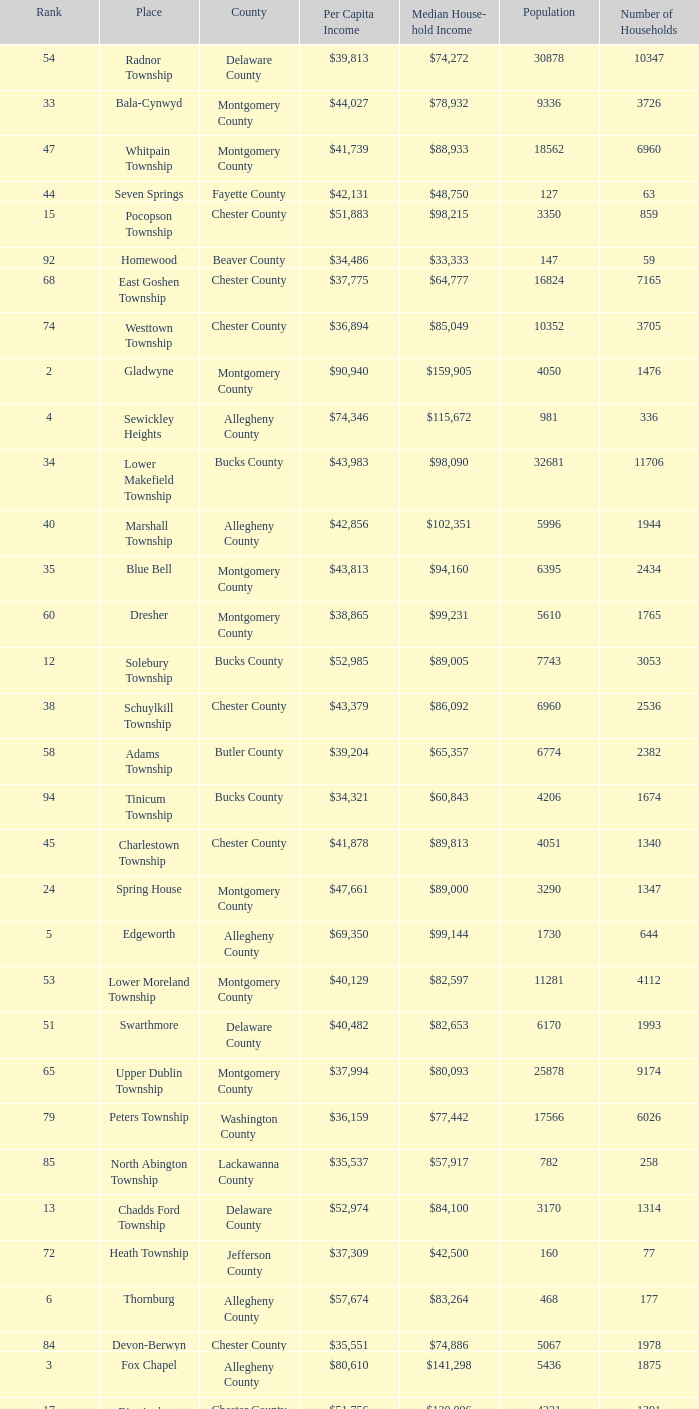Parse the full table. {'header': ['Rank', 'Place', 'County', 'Per Capita Income', 'Median House- hold Income', 'Population', 'Number of Households'], 'rows': [['54', 'Radnor Township', 'Delaware County', '$39,813', '$74,272', '30878', '10347'], ['33', 'Bala-Cynwyd', 'Montgomery County', '$44,027', '$78,932', '9336', '3726'], ['47', 'Whitpain Township', 'Montgomery County', '$41,739', '$88,933', '18562', '6960'], ['44', 'Seven Springs', 'Fayette County', '$42,131', '$48,750', '127', '63'], ['15', 'Pocopson Township', 'Chester County', '$51,883', '$98,215', '3350', '859'], ['92', 'Homewood', 'Beaver County', '$34,486', '$33,333', '147', '59'], ['68', 'East Goshen Township', 'Chester County', '$37,775', '$64,777', '16824', '7165'], ['74', 'Westtown Township', 'Chester County', '$36,894', '$85,049', '10352', '3705'], ['2', 'Gladwyne', 'Montgomery County', '$90,940', '$159,905', '4050', '1476'], ['4', 'Sewickley Heights', 'Allegheny County', '$74,346', '$115,672', '981', '336'], ['34', 'Lower Makefield Township', 'Bucks County', '$43,983', '$98,090', '32681', '11706'], ['40', 'Marshall Township', 'Allegheny County', '$42,856', '$102,351', '5996', '1944'], ['35', 'Blue Bell', 'Montgomery County', '$43,813', '$94,160', '6395', '2434'], ['60', 'Dresher', 'Montgomery County', '$38,865', '$99,231', '5610', '1765'], ['12', 'Solebury Township', 'Bucks County', '$52,985', '$89,005', '7743', '3053'], ['38', 'Schuylkill Township', 'Chester County', '$43,379', '$86,092', '6960', '2536'], ['58', 'Adams Township', 'Butler County', '$39,204', '$65,357', '6774', '2382'], ['94', 'Tinicum Township', 'Bucks County', '$34,321', '$60,843', '4206', '1674'], ['45', 'Charlestown Township', 'Chester County', '$41,878', '$89,813', '4051', '1340'], ['24', 'Spring House', 'Montgomery County', '$47,661', '$89,000', '3290', '1347'], ['5', 'Edgeworth', 'Allegheny County', '$69,350', '$99,144', '1730', '644'], ['53', 'Lower Moreland Township', 'Montgomery County', '$40,129', '$82,597', '11281', '4112'], ['51', 'Swarthmore', 'Delaware County', '$40,482', '$82,653', '6170', '1993'], ['65', 'Upper Dublin Township', 'Montgomery County', '$37,994', '$80,093', '25878', '9174'], ['79', 'Peters Township', 'Washington County', '$36,159', '$77,442', '17566', '6026'], ['85', 'North Abington Township', 'Lackawanna County', '$35,537', '$57,917', '782', '258'], ['13', 'Chadds Ford Township', 'Delaware County', '$52,974', '$84,100', '3170', '1314'], ['72', 'Heath Township', 'Jefferson County', '$37,309', '$42,500', '160', '77'], ['6', 'Thornburg', 'Allegheny County', '$57,674', '$83,264', '468', '177'], ['84', 'Devon-Berwyn', 'Chester County', '$35,551', '$74,886', '5067', '1978'], ['3', 'Fox Chapel', 'Allegheny County', '$80,610', '$141,298', '5436', '1875'], ['17', 'Birmingham Township', 'Chester County', '$51,756', '$130,096', '4221', '1391'], ['19', 'Easttown Township', 'Chester County', '$51,028', '$95,548', '10270', '3758'], ['80', 'Ardmore', 'Montgomery County', '$36,111', '$60,966', '12616', '5529'], ['31', 'Abington Township', 'Lackawanna County', '$44,551', '$73,611', '1616', '609'], ['77', 'Newlin Township', 'Chester County', '$36,804', '$68,828', '1150', '429'], ['21', 'Osborne', 'Allegheny County', '$50,169', '$64,375', '566', '216'], ['76', 'Flying Hills', 'Berks County', '$36,822', '$59,596', '1191', '592'], ['25', 'Tredyffrin Township', 'Chester County', '$47,584', '$82,258', '29062', '12223'], ['64', 'Doylestown Township', 'Bucks County', '$38,031', '$81,226', '17619', '5999'], ['63', 'East Marlborough Township', 'Chester County', '$38,090', '$95,812', '6317', '2131'], ['82', 'London Britain Township', 'Chester County', '$35,761', '$93,521', '2797', '957'], ['1', 'Norwin', 'Westmoreland County', '$124,279', '$94,239', '18', '7'], ['96', 'Wyomissing Hills', 'Berks County', '$34,024', '$61,364', '2568', '986'], ['56', 'Upper Providence Township', 'Delaware County', '$39,532', '$71,166', '10509', '4075'], ['23', 'Spring Ridge', 'Berks County', '$47,822', '$83,345', '786', '370'], ['28', 'Kennett Township', 'Chester County', '$46,669', '$85,104', '6451', '2457'], ['73', 'Aleppo Township', 'Allegheny County', '$37,187', '$59,167', '1039', '483'], ['49', 'Penn Wynne', 'Montgomery County', '$41,199', '$78,398', '5382', '2072'], ['36', 'West Vincent Township', 'Chester County', '$43,500', '$92,024', '3170', '1077'], ['26', 'Thornbury Township', 'Chester County', '$47,505', '$84,225', '2678', '1023'], ['18', 'Bradford Woods', 'Allegheny County', '$51,462', '$92,820', '1149', '464'], ['66', 'Churchill', 'Allegheny County', '$37,964', '$67,321', '3566', '1519'], ['11', 'Haysville', 'Allegheny County', '$53,151', '$33,750', '78', '36'], ['22', 'West Pikeland Township', 'Chester County', '$48,616', '$105,322', '3551', '1214'], ['59', 'Edgewood', 'Allegheny County', '$39,188', '$52,153', '3311', '1639'], ['43', 'Upper St.Clair Township', 'Allegheny County', '$42,413', '$87,581', '20053', '6966'], ['90', 'Timber Hills', 'Lebanon County', '$34,974', '$55,938', '329', '157'], ['57', 'Newtown Township', 'Delaware County', '$39,364', '$65,924', '11700', '4549'], ['67', 'Franklin Park', 'Allegheny County', '$37,924', '$87,627', '11364', '3866'], ['61', 'Sewickley Hills', 'Allegheny County', '$38,681', '$79,466', '652', '225'], ['62', 'Exton', 'Chester County', '$38,589', '$68,240', '4267', '2053'], ['91', 'Upper Merion Township', 'Montgomery County', '$34,961', '$65,636', '26863', '11575'], ['27', 'Edgmont Township', 'Delaware County', '$46,848', '$88,303', '3918', '1447'], ['98', 'Concord Township', 'Delaware County', '$33,800', '$85,503', '9933', '3384'], ['41', 'Woodside', 'Bucks County', '$42,653', '$121,151', '2575', '791'], ['29', 'New Hope', 'Bucks County', '$45,309', '$60,833', '2252', '1160'], ['30', 'Willistown', 'Chester County', '$45,010', '$77,555', '10011', '3806'], ['9', 'Lower Merion Township', 'Montgomery County', '$55,526', '$86,373', '59850', '22868'], ['93', 'Newtown Township', 'Bucks County', '$34,335', '$80,532', '18206', '6761'], ['37', 'Mount Gretna', 'Lebanon County', '$43,470', '$62,917', '242', '117'], ['32', 'Ben Avon Heights', 'Allegheny County', '$44,191', '$105,006', '392', '138'], ['86', 'Malvern', 'Chester County', '$35,477', '$62,308', '3059', '1361'], ['52', 'Lafayette Hill', 'Montgomery County', '$40,363', '$84,835', '10226', '3783'], ['42', 'Wrightstown Township', 'Bucks County', '$42,623', '$82,875', '2839', '971'], ['8', 'Upper Makefield Township', 'Bucks County', '$56,288', '$102,759', '7180', '2512'], ['83', 'Buckingham Township', 'Bucks County', '$35,735', '$82,376', '16422', '5711'], ['46', 'Lower Gwynedd Township', 'Montgomery County', '$41,868', '$74,351', '10422', '4177'], ['50', 'East Bradford Township', 'Chester County', '$41,158', '$100,732', '9405', '3076'], ['71', 'Wyomissing', 'Berks County', '$37,313', '$54,681', '8587', '3359'], ['14', 'Pennsbury Township', 'Chester County', '$52,530', '$83,295', '3500', '1387'], ['48', 'Bell Acres', 'Allegheny County', '$41,202', '$61,094', '1382', '520'], ['20', 'Villanova', 'Montgomery County', '$50,204', '$159,538', '9060', '1902'], ['16', 'Chesterbrook', 'Chester County', '$51,859', '$80,792', '4625', '2356'], ['7', 'Rosslyn Farms', 'Allegheny County', '$56,612', '$87,500', '464', '184'], ['89', 'West Whiteland Township', 'Chester County', '$35,031', '$71,545', '16499', '6618'], ['10', 'Rose Valley', 'Delaware County', '$54,202', '$114,373', '944', '347'], ['55', 'Whitemarsh Township', 'Montgomery County', '$39,785', '$78,630', '16702', '6179'], ['87', 'Pine Township', 'Allegheny County', '$35,202', '$85,817', '7683', '2411'], ['97', 'Woodbourne', 'Bucks County', '$33,821', '$107,913', '3512', '1008'], ['78', 'Wyndmoor', 'Montgomery County', '$36,205', '$72,219', '5601', '2144'], ['39', 'Fort Washington', 'Montgomery County', '$43,090', '$103,469', '3680', '1161'], ['95', 'Worcester Township', 'Montgomery County', '$34,264', '$77,200', '7789', '2896'], ['75', 'Thompsonville', 'Washington County', '$36,853', '$75,000', '3592', '1228'], ['88', 'Narberth', 'Montgomery County', '$35,165', '$60,408', '4233', '1904'], ['99', 'Uwchlan Township', 'Chester County', '$33,785', '$81,985', '16576', '5921'], ['69', 'Chester Heights', 'Delaware County', '$37,707', '$70,236', '2481', '1056'], ['81', 'Clarks Green', 'Lackawanna County', '$35,975', '$61,250', '1630', '616'], ['70', 'McMurray', 'Washington County', '$37,364', '$81,736', '4726', '1582']]} What is the median household income for Woodside? $121,151. 